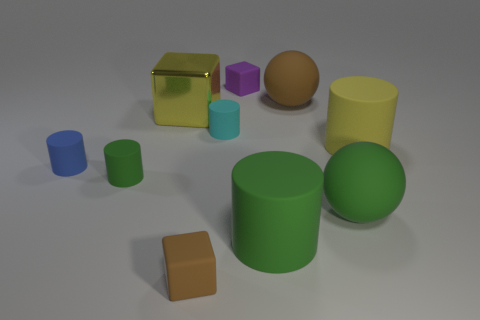Is the size of the brown cube the same as the brown rubber ball?
Your answer should be compact. No. There is a cube that is on the right side of the yellow block and behind the blue object; what is its material?
Your answer should be compact. Rubber. What number of large metal objects have the same shape as the tiny purple object?
Provide a short and direct response. 1. There is a brown thing behind the tiny brown cube; what is its material?
Your answer should be very brief. Rubber. Are there fewer green spheres left of the cyan thing than large yellow rubber things?
Provide a short and direct response. Yes. Does the yellow matte object have the same shape as the large yellow metal thing?
Give a very brief answer. No. Is there any other thing that has the same shape as the blue matte thing?
Provide a short and direct response. Yes. Are there any brown objects?
Your answer should be compact. Yes. There is a tiny cyan thing; is it the same shape as the brown matte thing to the left of the purple matte block?
Offer a very short reply. No. What is the material of the tiny block that is in front of the large matte cylinder behind the small green cylinder?
Make the answer very short. Rubber. 